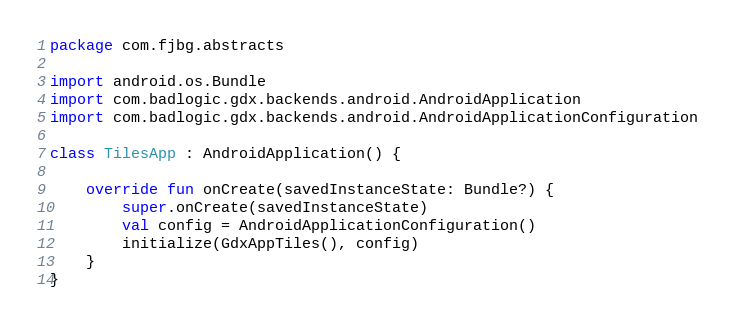Convert code to text. <code><loc_0><loc_0><loc_500><loc_500><_Kotlin_>package com.fjbg.abstracts

import android.os.Bundle
import com.badlogic.gdx.backends.android.AndroidApplication
import com.badlogic.gdx.backends.android.AndroidApplicationConfiguration

class TilesApp : AndroidApplication() {

    override fun onCreate(savedInstanceState: Bundle?) {
        super.onCreate(savedInstanceState)
        val config = AndroidApplicationConfiguration()
        initialize(GdxAppTiles(), config)
    }
}</code> 